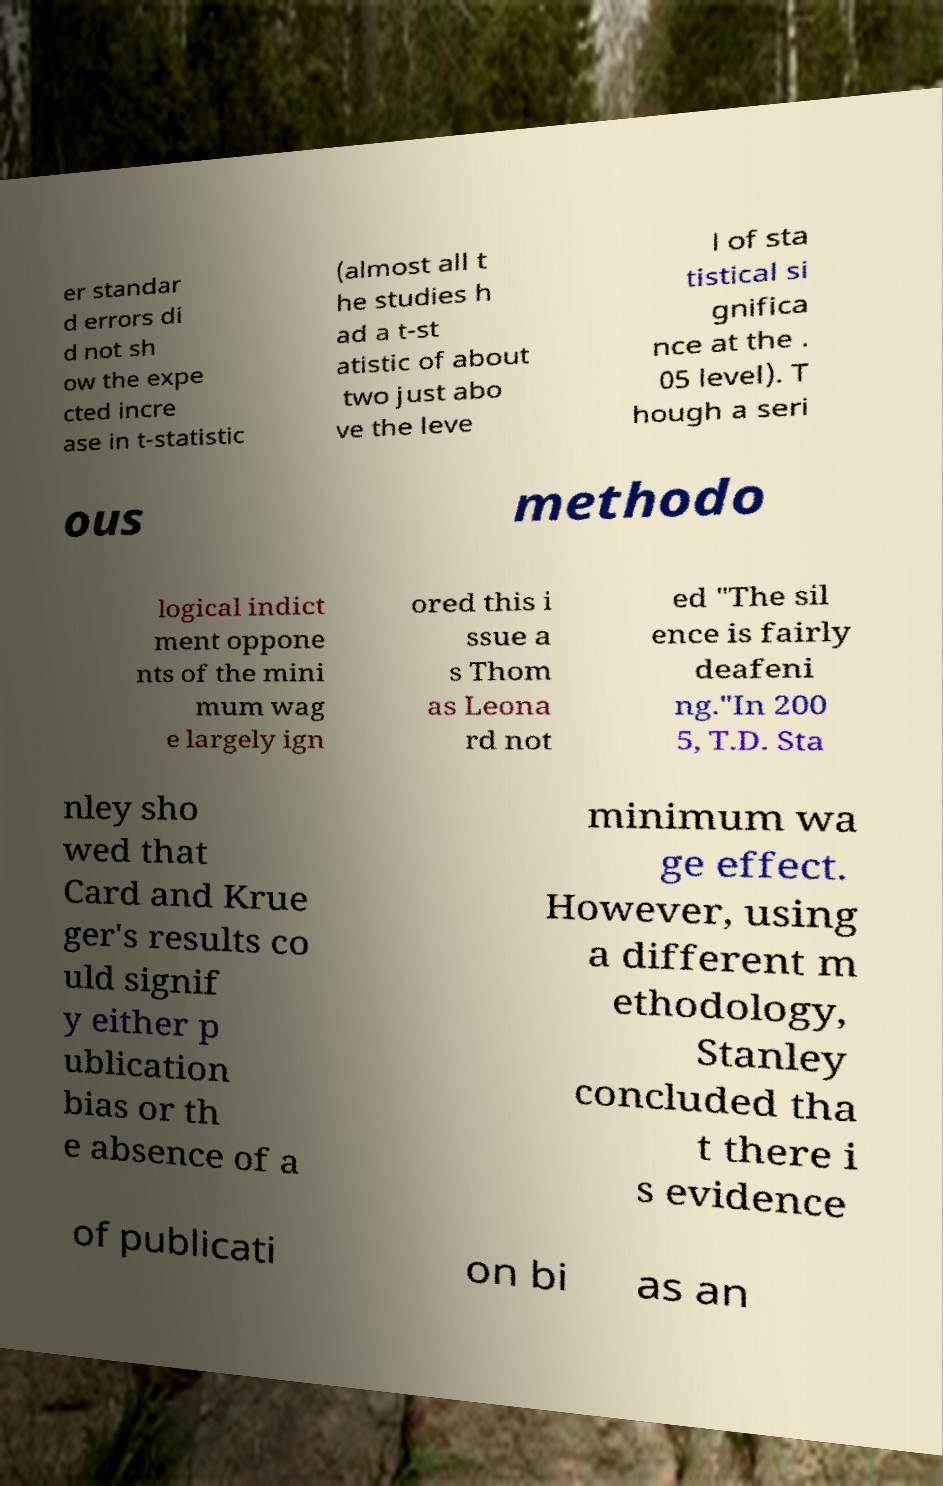Could you extract and type out the text from this image? er standar d errors di d not sh ow the expe cted incre ase in t-statistic (almost all t he studies h ad a t-st atistic of about two just abo ve the leve l of sta tistical si gnifica nce at the . 05 level). T hough a seri ous methodo logical indict ment oppone nts of the mini mum wag e largely ign ored this i ssue a s Thom as Leona rd not ed "The sil ence is fairly deafeni ng."In 200 5, T.D. Sta nley sho wed that Card and Krue ger's results co uld signif y either p ublication bias or th e absence of a minimum wa ge effect. However, using a different m ethodology, Stanley concluded tha t there i s evidence of publicati on bi as an 